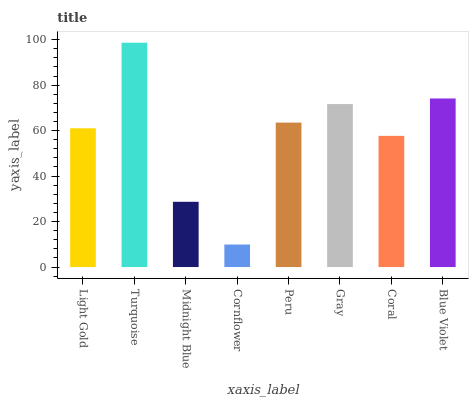Is Cornflower the minimum?
Answer yes or no. Yes. Is Turquoise the maximum?
Answer yes or no. Yes. Is Midnight Blue the minimum?
Answer yes or no. No. Is Midnight Blue the maximum?
Answer yes or no. No. Is Turquoise greater than Midnight Blue?
Answer yes or no. Yes. Is Midnight Blue less than Turquoise?
Answer yes or no. Yes. Is Midnight Blue greater than Turquoise?
Answer yes or no. No. Is Turquoise less than Midnight Blue?
Answer yes or no. No. Is Peru the high median?
Answer yes or no. Yes. Is Light Gold the low median?
Answer yes or no. Yes. Is Gray the high median?
Answer yes or no. No. Is Coral the low median?
Answer yes or no. No. 